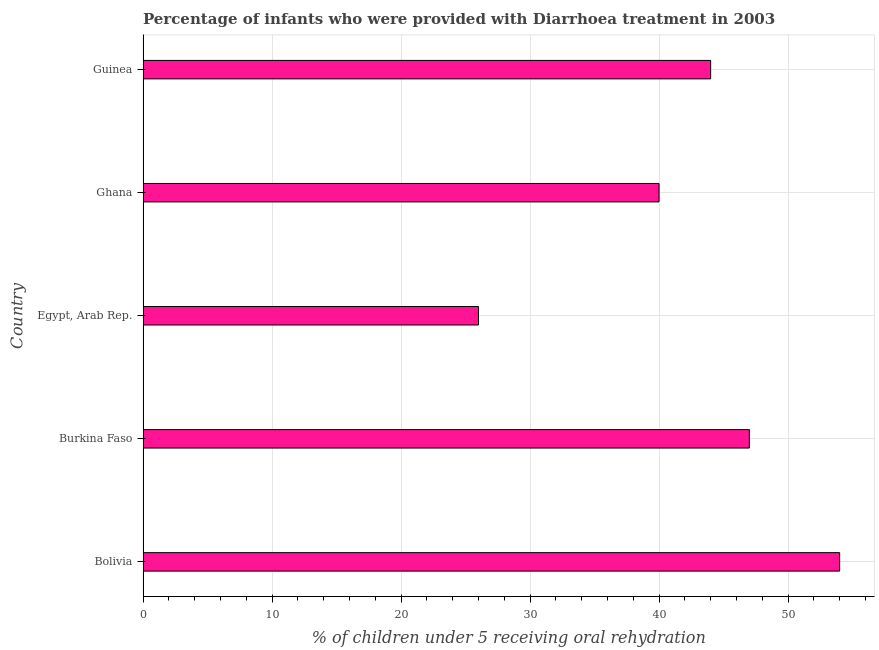What is the title of the graph?
Offer a very short reply. Percentage of infants who were provided with Diarrhoea treatment in 2003. What is the label or title of the X-axis?
Offer a terse response. % of children under 5 receiving oral rehydration. In which country was the percentage of children who were provided with treatment diarrhoea maximum?
Your response must be concise. Bolivia. In which country was the percentage of children who were provided with treatment diarrhoea minimum?
Provide a succinct answer. Egypt, Arab Rep. What is the sum of the percentage of children who were provided with treatment diarrhoea?
Your answer should be very brief. 211. What is the average percentage of children who were provided with treatment diarrhoea per country?
Offer a very short reply. 42. What is the ratio of the percentage of children who were provided with treatment diarrhoea in Bolivia to that in Ghana?
Offer a very short reply. 1.35. Is the difference between the percentage of children who were provided with treatment diarrhoea in Bolivia and Ghana greater than the difference between any two countries?
Your answer should be very brief. No. Is the sum of the percentage of children who were provided with treatment diarrhoea in Burkina Faso and Ghana greater than the maximum percentage of children who were provided with treatment diarrhoea across all countries?
Provide a succinct answer. Yes. What is the difference between the highest and the lowest percentage of children who were provided with treatment diarrhoea?
Make the answer very short. 28. How many bars are there?
Your answer should be very brief. 5. How many countries are there in the graph?
Your answer should be compact. 5. What is the % of children under 5 receiving oral rehydration of Bolivia?
Your answer should be compact. 54. What is the difference between the % of children under 5 receiving oral rehydration in Bolivia and Burkina Faso?
Give a very brief answer. 7. What is the difference between the % of children under 5 receiving oral rehydration in Bolivia and Egypt, Arab Rep.?
Ensure brevity in your answer.  28. What is the difference between the % of children under 5 receiving oral rehydration in Bolivia and Guinea?
Offer a very short reply. 10. What is the difference between the % of children under 5 receiving oral rehydration in Burkina Faso and Egypt, Arab Rep.?
Ensure brevity in your answer.  21. What is the ratio of the % of children under 5 receiving oral rehydration in Bolivia to that in Burkina Faso?
Offer a very short reply. 1.15. What is the ratio of the % of children under 5 receiving oral rehydration in Bolivia to that in Egypt, Arab Rep.?
Give a very brief answer. 2.08. What is the ratio of the % of children under 5 receiving oral rehydration in Bolivia to that in Ghana?
Your response must be concise. 1.35. What is the ratio of the % of children under 5 receiving oral rehydration in Bolivia to that in Guinea?
Offer a very short reply. 1.23. What is the ratio of the % of children under 5 receiving oral rehydration in Burkina Faso to that in Egypt, Arab Rep.?
Make the answer very short. 1.81. What is the ratio of the % of children under 5 receiving oral rehydration in Burkina Faso to that in Ghana?
Your answer should be very brief. 1.18. What is the ratio of the % of children under 5 receiving oral rehydration in Burkina Faso to that in Guinea?
Ensure brevity in your answer.  1.07. What is the ratio of the % of children under 5 receiving oral rehydration in Egypt, Arab Rep. to that in Ghana?
Ensure brevity in your answer.  0.65. What is the ratio of the % of children under 5 receiving oral rehydration in Egypt, Arab Rep. to that in Guinea?
Provide a short and direct response. 0.59. What is the ratio of the % of children under 5 receiving oral rehydration in Ghana to that in Guinea?
Your response must be concise. 0.91. 